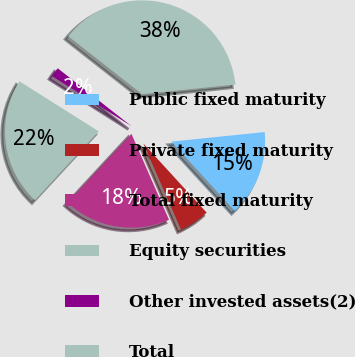<chart> <loc_0><loc_0><loc_500><loc_500><pie_chart><fcel>Public fixed maturity<fcel>Private fixed maturity<fcel>Total fixed maturity<fcel>Equity securities<fcel>Other invested assets(2)<fcel>Total<nl><fcel>14.84%<fcel>5.24%<fcel>18.45%<fcel>22.07%<fcel>1.63%<fcel>37.78%<nl></chart> 